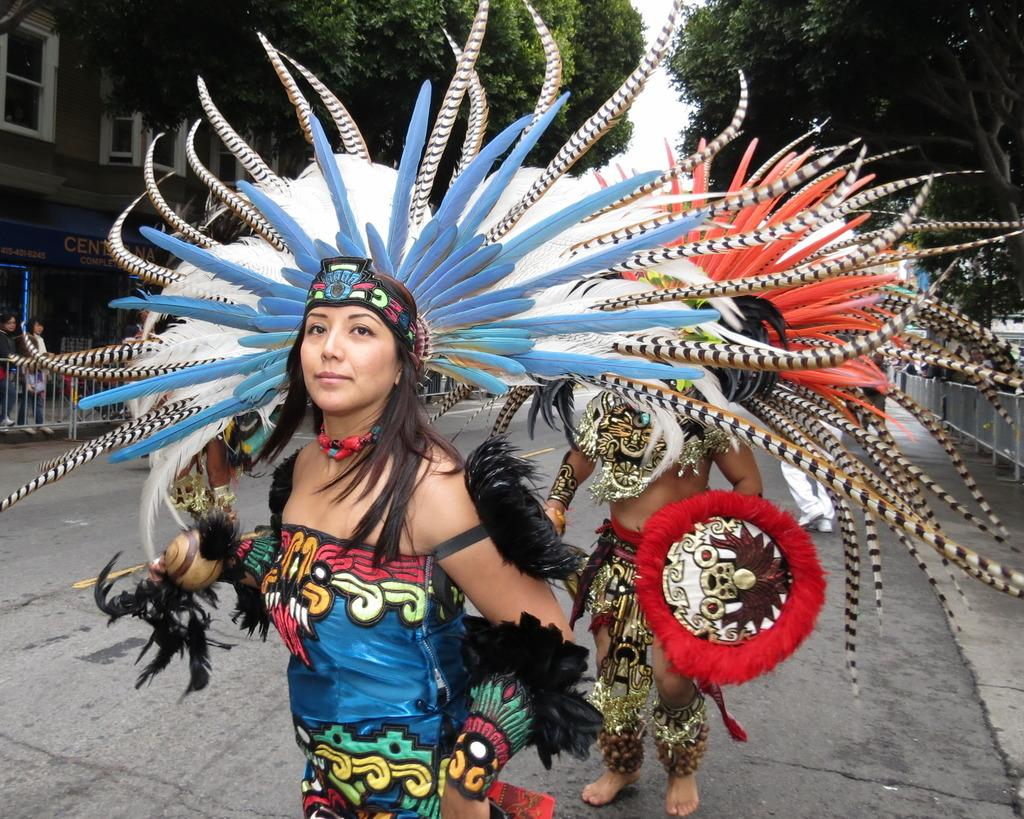What are the people in the image doing? There are people dancing in the image. What type of natural elements can be seen in the image? There are trees in the image. What type of man-made structures are present in the image? There are buildings in the image. What are some other activities that people are engaged in within the image? There are people walking in the image. How does the account balance increase in the image? There is no mention of an account or balance in the image, so it cannot be determined how it might increase. 